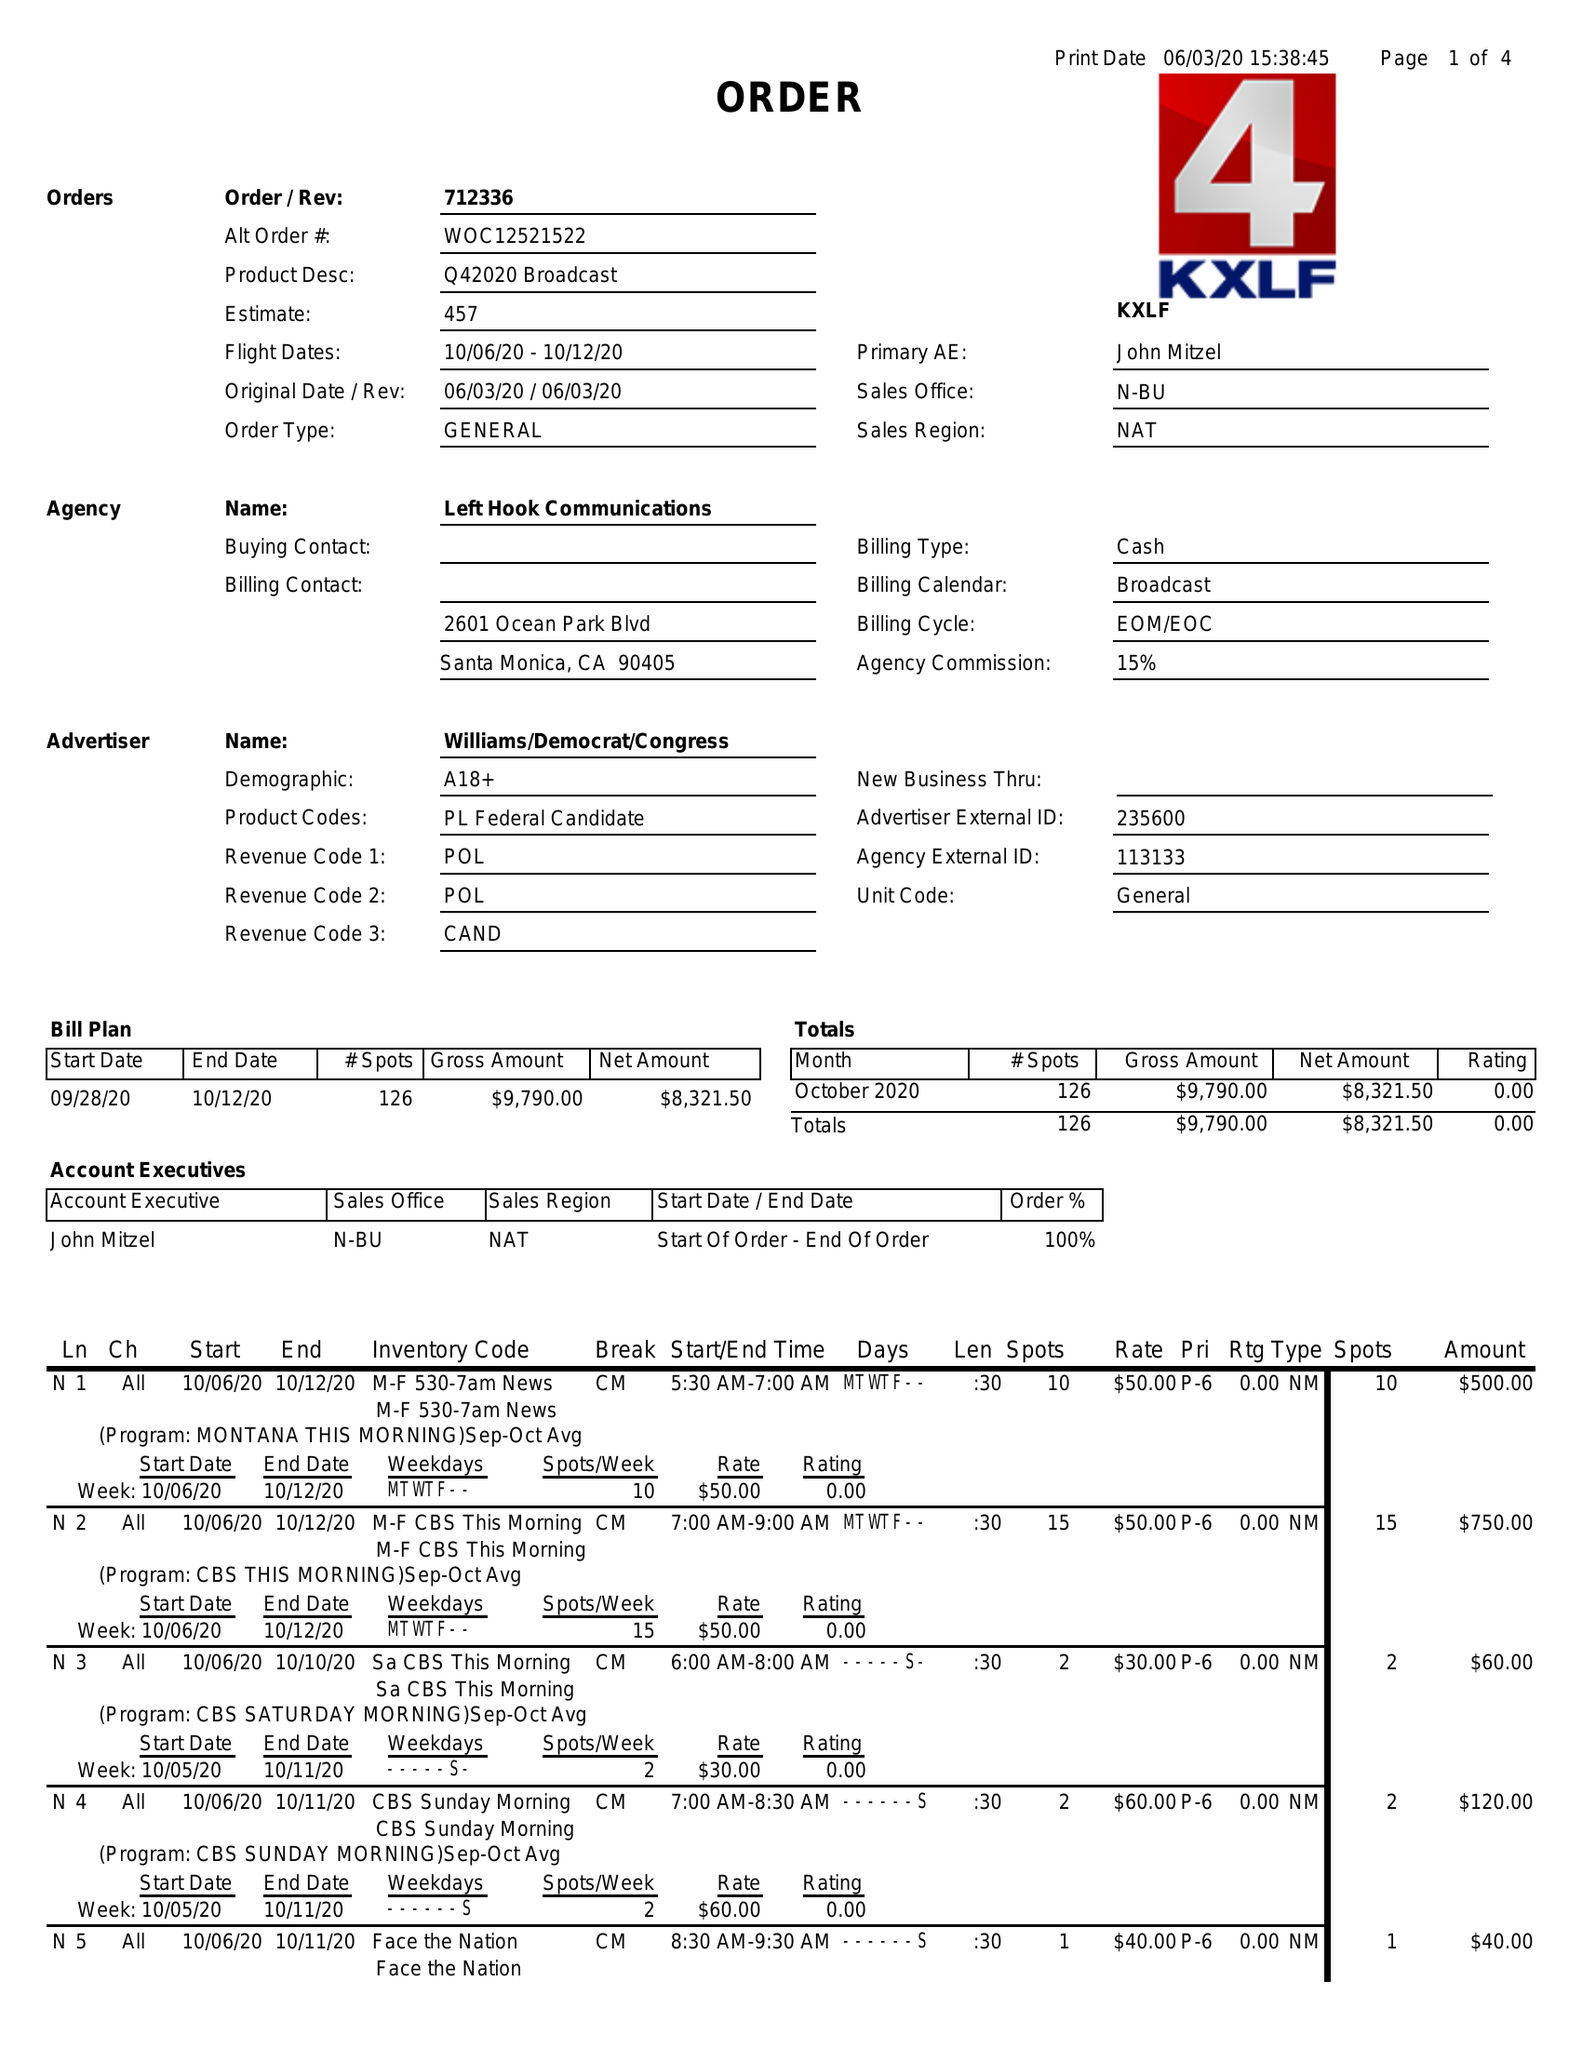What is the value for the flight_to?
Answer the question using a single word or phrase. 10/12/20 